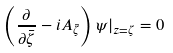<formula> <loc_0><loc_0><loc_500><loc_500>\left ( \frac { \partial } { \partial \bar { \zeta } } - i A _ { \bar { \zeta } } \right ) \psi | _ { z = \zeta } = 0</formula> 